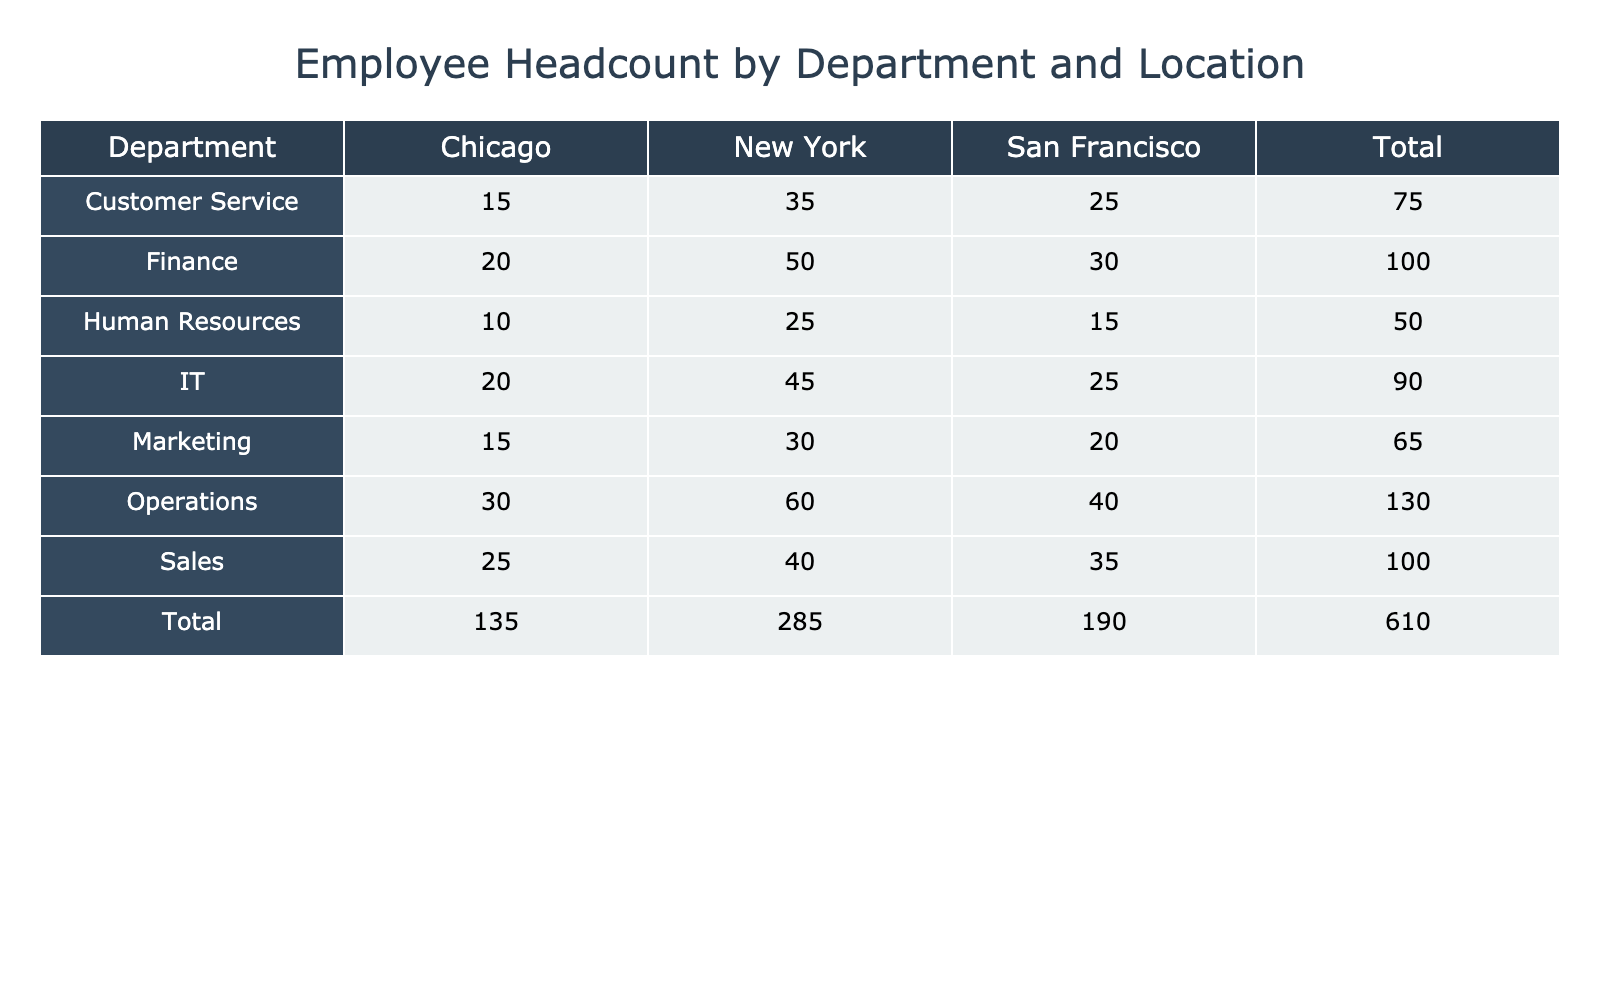What is the total headcount in the Sales department? The Sales department has headcounts of 40 in New York, 35 in San Francisco, and 25 in Chicago. To find the total, we sum these values: 40 + 35 + 25 = 100
Answer: 100 Which location has the highest headcount in the Operations department? The Operations department has 60 in New York, 40 in San Francisco, and 30 in Chicago. The highest among these is 60 in New York
Answer: New York Is the headcount in the IT department greater than that in the Customer Service department? The IT department has total headcounts of 45 in New York, 25 in San Francisco, and 20 in Chicago, summing up to 90. The Customer Service department has total headcounts of 35 in New York, 25 in San Francisco, and 15 in Chicago, summing to 75. Since 90 is greater than 75, the headcount in IT is indeed greater
Answer: Yes What is the average headcount in San Francisco across all departments? The headcounts in San Francisco are: Finance 30, Human Resources 15, Sales 35, Marketing 20, IT 25, Operations 40, and Customer Service 25. Summing these values gives 30 + 15 + 35 + 20 + 25 + 40 + 25 = 200. There are 7 departments, so the average headcount is 200 / 7 ≈ 28.57
Answer: Approximately 28.57 In which department is the total headcount the lowest? By examining the total headcounts for each department: Finance (100), Human Resources (50), Sales (100), Marketing (65), IT (90), Operations (130), and Customer Service (75), the lowest total is 50 for the Human Resources department
Answer: Human Resources 